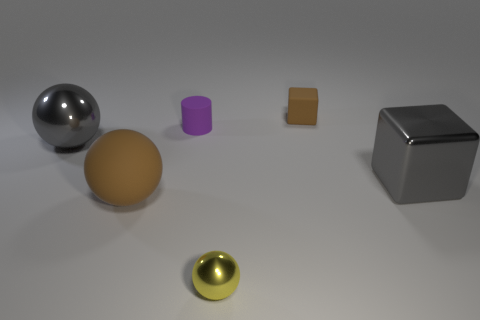What shape is the small matte object that is the same color as the large matte object?
Provide a succinct answer. Cube. Does the brown object that is left of the tiny yellow thing have the same size as the shiny object left of the small sphere?
Your answer should be compact. Yes. There is a brown rubber object that is on the left side of the tiny yellow shiny ball; what is its shape?
Offer a terse response. Sphere. What material is the big gray thing that is on the right side of the rubber object that is in front of the big gray shiny cube made of?
Your answer should be very brief. Metal. Is there another big shiny cube that has the same color as the large metal block?
Keep it short and to the point. No. There is a purple object; is it the same size as the shiny thing that is left of the tiny cylinder?
Offer a very short reply. No. How many yellow metallic balls are in front of the gray object on the left side of the block that is in front of the tiny cylinder?
Ensure brevity in your answer.  1. There is a small purple matte thing; what number of tiny brown matte blocks are left of it?
Offer a terse response. 0. The rubber thing in front of the shiny sphere behind the yellow shiny sphere is what color?
Provide a short and direct response. Brown. Is the number of tiny purple cylinders right of the large block the same as the number of large shiny balls?
Provide a succinct answer. No. 